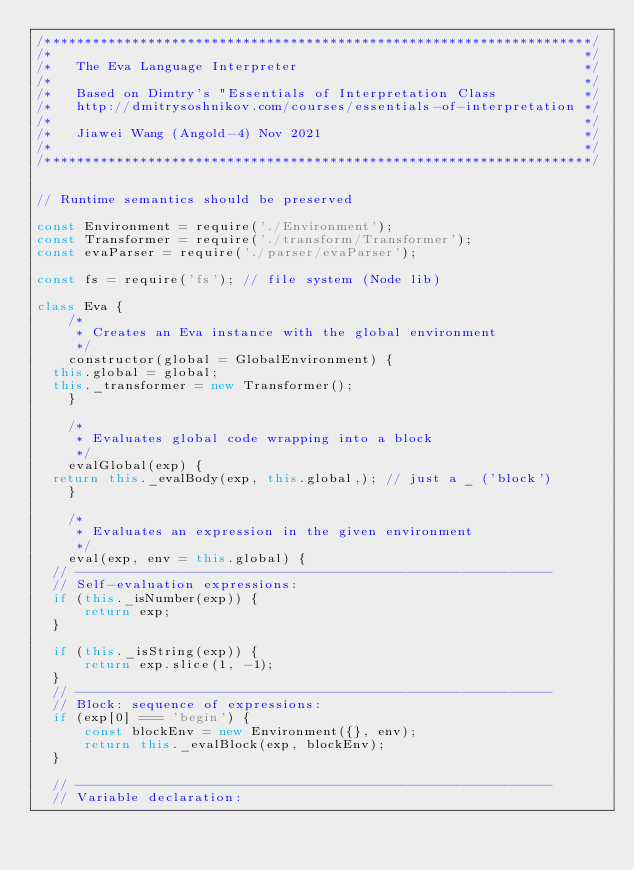<code> <loc_0><loc_0><loc_500><loc_500><_JavaScript_>/*********************************************************************/
/*                                                                   */
/*   The Eva Language Interpreter                                    */
/*                                                                   */
/*   Based on Dimtry's "Essentials of Interpretation Class           */
/*   http://dmitrysoshnikov.com/courses/essentials-of-interpretation */
/*                                                                   */
/*   Jiawei Wang (Angold-4) Nov 2021                                 */ 
/*                                                                   */
/*********************************************************************/


// Runtime semantics should be preserved

const Environment = require('./Environment');
const Transformer = require('./transform/Transformer');
const evaParser = require('./parser/evaParser');

const fs = require('fs'); // file system (Node lib)

class Eva {
    /*
     * Creates an Eva instance with the global environment
     */
    constructor(global = GlobalEnvironment) {
	this.global = global;
	this._transformer = new Transformer();
    }

    /*
     * Evaluates global code wrapping into a block
     */
    evalGlobal(exp) {
	return this._evalBody(exp, this.global,); // just a _ ('block')
    }

    /*
     * Evaluates an expression in the given environment
     */
    eval(exp, env = this.global) {
	// ------------------------------------------------------------
	// Self-evaluation expressions:
	if (this._isNumber(exp)) {
	    return exp;
	}

	if (this._isString(exp)) {
	    return exp.slice(1, -1);
	}
	// ------------------------------------------------------------
	// Block: sequence of expressions:
	if (exp[0] === 'begin') {
	    const blockEnv = new Environment({}, env);
	    return this._evalBlock(exp, blockEnv);
	}

	// ------------------------------------------------------------
	// Variable declaration:</code> 